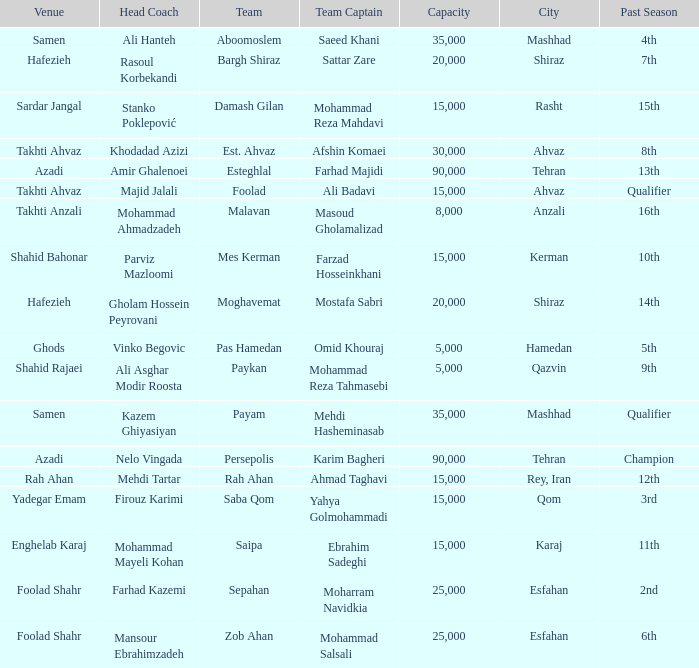What is the Capacity of the Venue of Head Coach Ali Asghar Modir Roosta? 5000.0. 